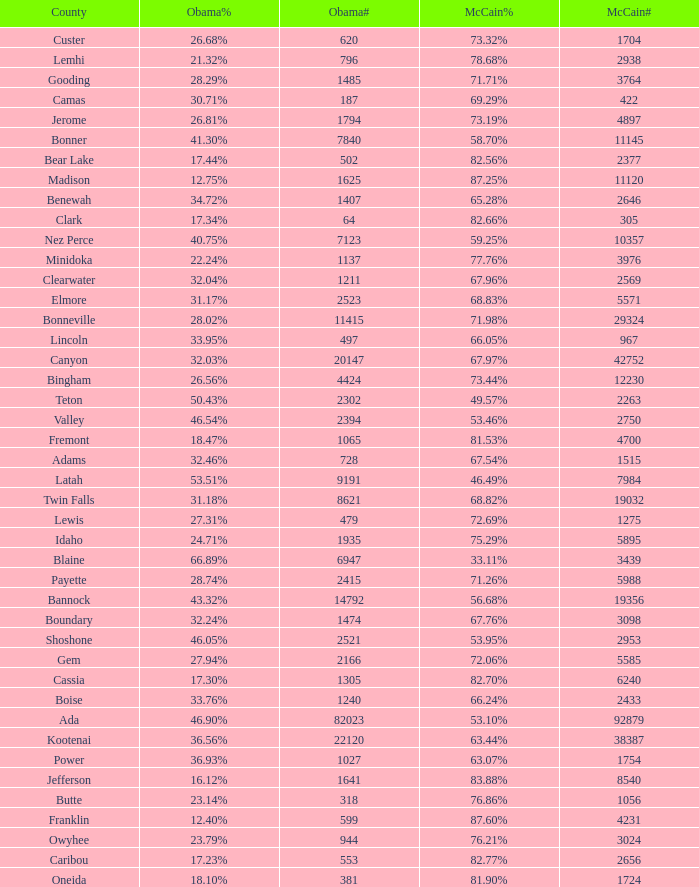What is the maximum McCain population turnout number? 92879.0. 